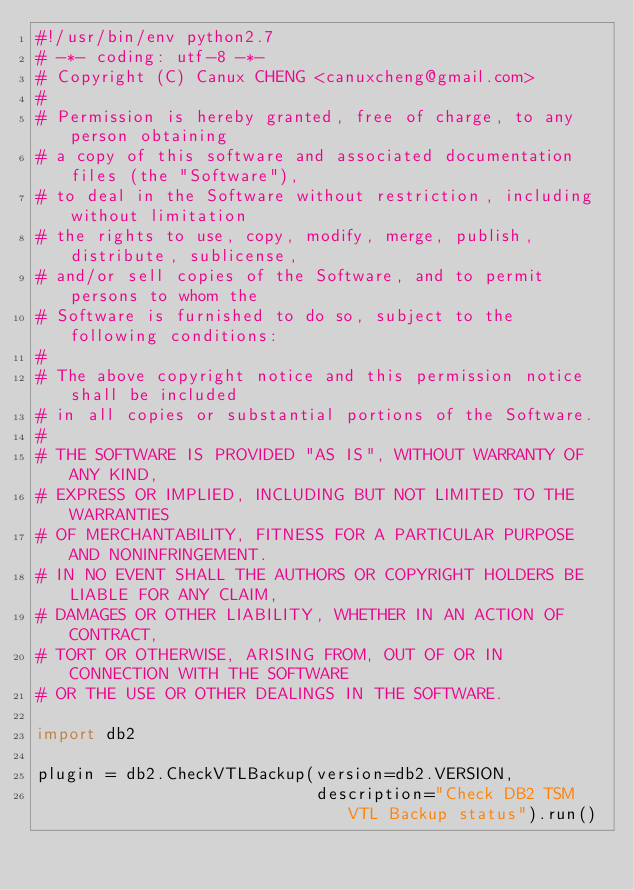<code> <loc_0><loc_0><loc_500><loc_500><_Python_>#!/usr/bin/env python2.7
# -*- coding: utf-8 -*-
# Copyright (C) Canux CHENG <canuxcheng@gmail.com>
#
# Permission is hereby granted, free of charge, to any person obtaining
# a copy of this software and associated documentation files (the "Software"),
# to deal in the Software without restriction, including without limitation
# the rights to use, copy, modify, merge, publish, distribute, sublicense,
# and/or sell copies of the Software, and to permit persons to whom the
# Software is furnished to do so, subject to the following conditions:
#
# The above copyright notice and this permission notice shall be included
# in all copies or substantial portions of the Software.
#
# THE SOFTWARE IS PROVIDED "AS IS", WITHOUT WARRANTY OF ANY KIND,
# EXPRESS OR IMPLIED, INCLUDING BUT NOT LIMITED TO THE WARRANTIES
# OF MERCHANTABILITY, FITNESS FOR A PARTICULAR PURPOSE AND NONINFRINGEMENT.
# IN NO EVENT SHALL THE AUTHORS OR COPYRIGHT HOLDERS BE LIABLE FOR ANY CLAIM,
# DAMAGES OR OTHER LIABILITY, WHETHER IN AN ACTION OF CONTRACT,
# TORT OR OTHERWISE, ARISING FROM, OUT OF OR IN CONNECTION WITH THE SOFTWARE
# OR THE USE OR OTHER DEALINGS IN THE SOFTWARE.

import db2

plugin = db2.CheckVTLBackup(version=db2.VERSION,
                            description="Check DB2 TSM VTL Backup status").run()
</code> 